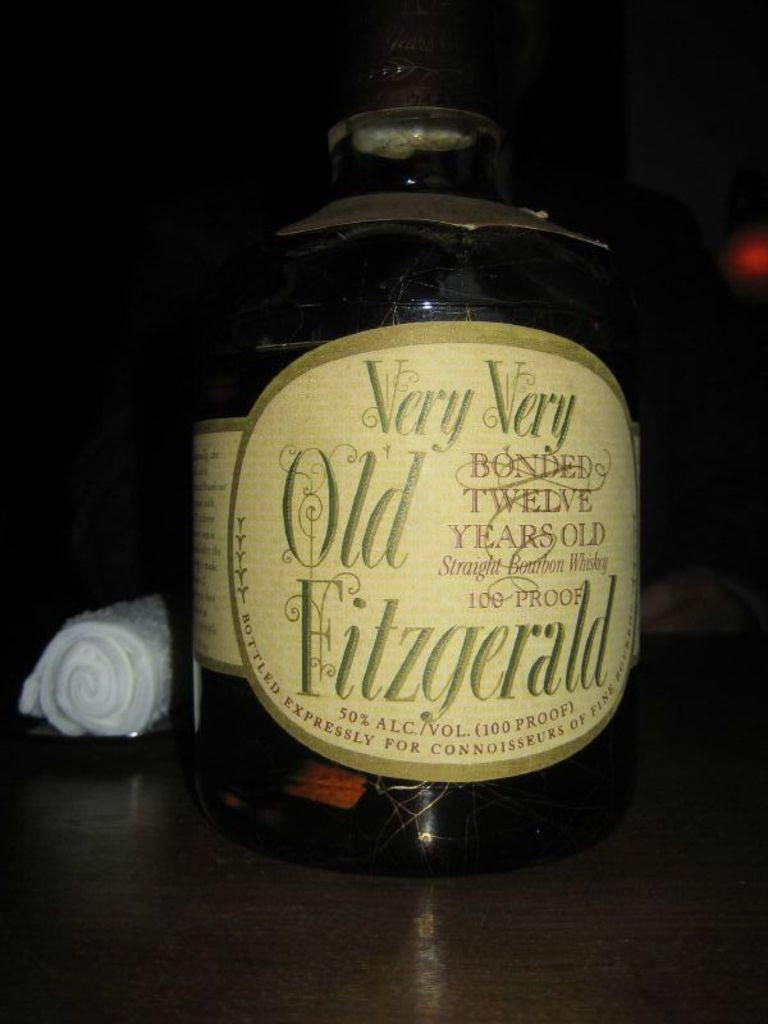<image>
Render a clear and concise summary of the photo. A large bottle of old Fitzgerald sits in a dark setting 